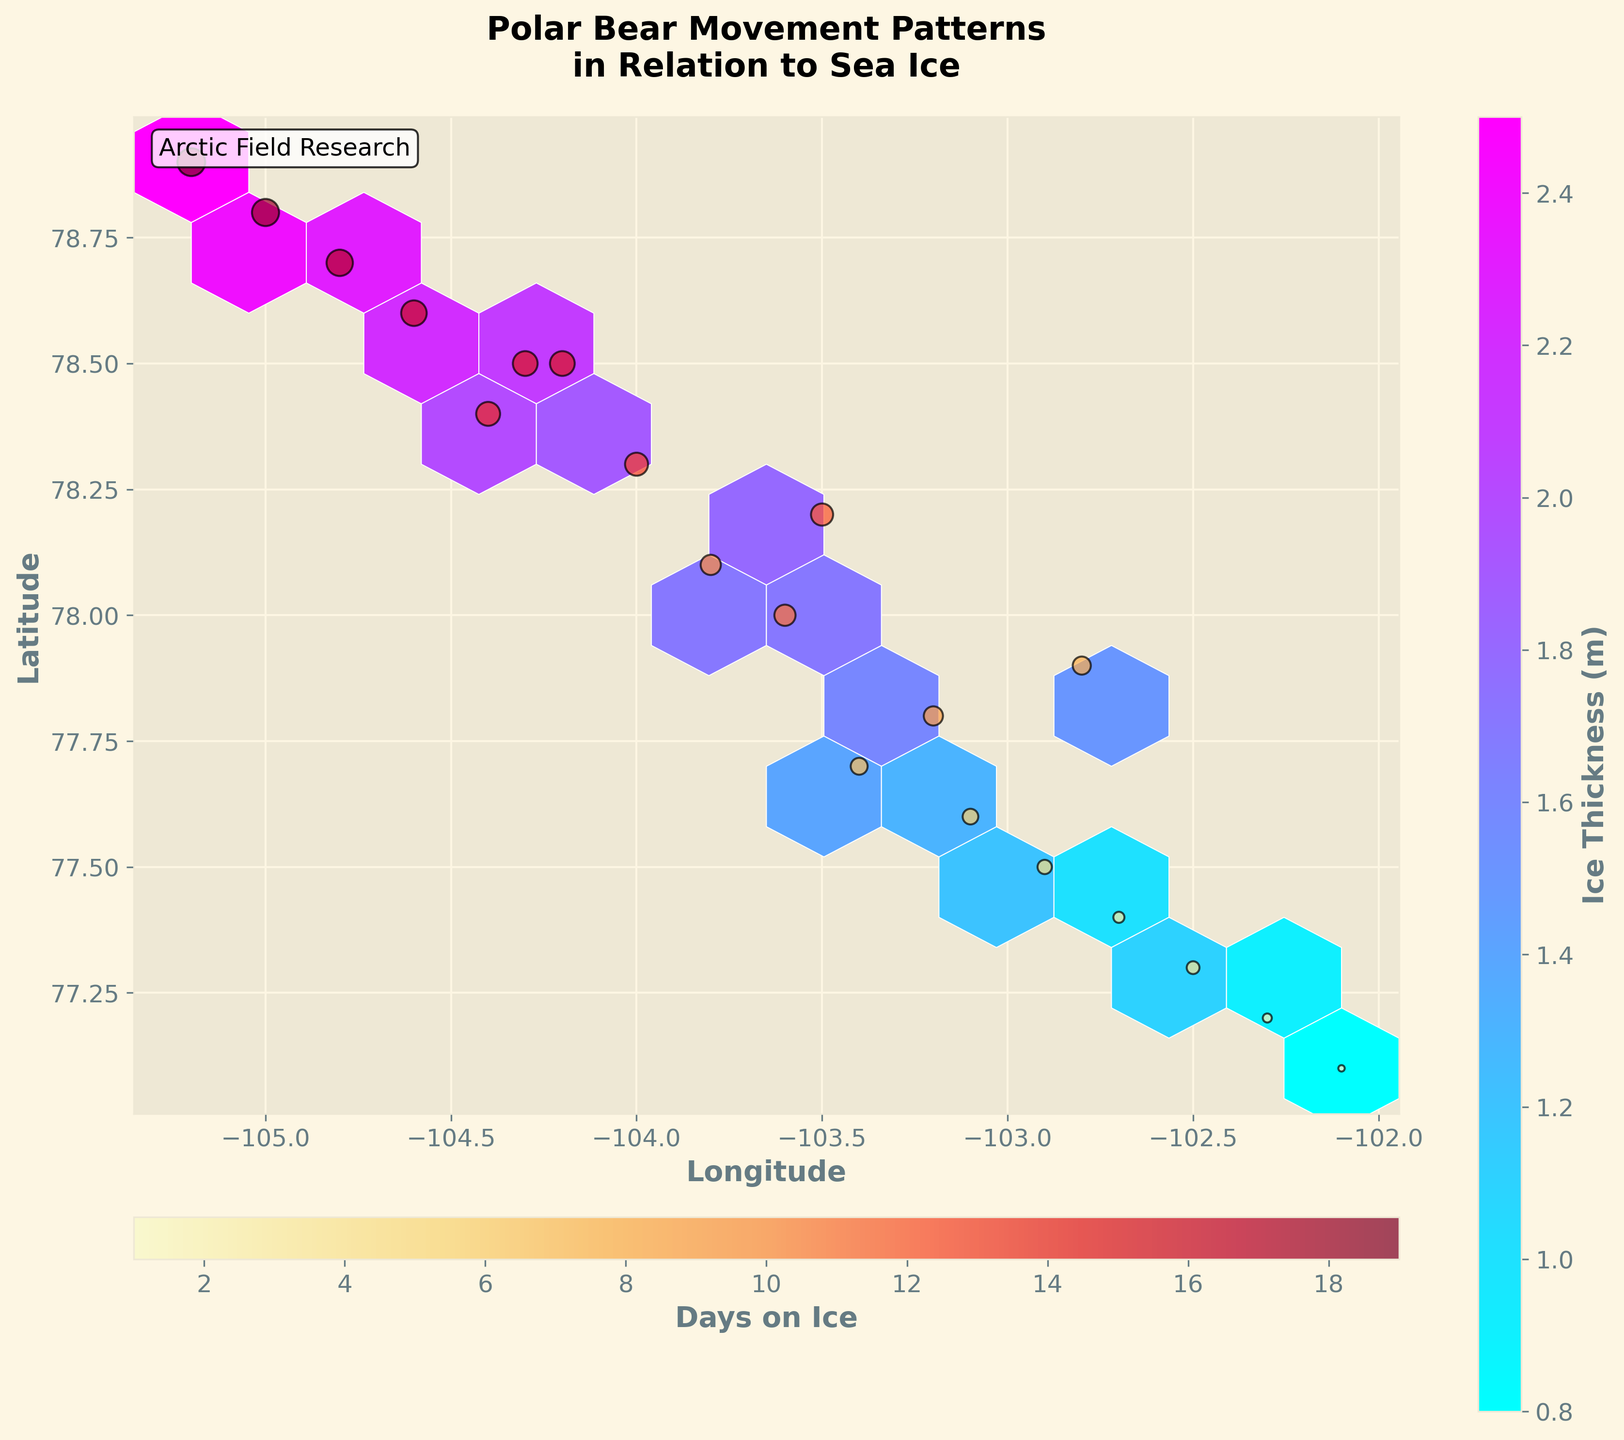What is the title of the hexbin plot? The title can be found at the top of the plot and is written in a bold, readable font.
Answer: Polar Bear Movement Patterns in Relation to Sea Ice What are the labels for the x-axis and y-axis on the plot? The x-axis and y-axis labels are located along the horizontal and vertical axes respectively, written in bold typeface for easy readability.
Answer: Longitude, Latitude Which color scale represents ice thickness? The color scale representing ice thickness is indicated by the color bar on the right side of the plot, which is labeled 'Ice Thickness (m)' and uses the 'cool' colormap.
Answer: cool What colormap is used for the 'Days on Ice' scatter plot? The colormap for the scatter plot 'Days on Ice' is shown near the second color bar at the bottom of the plot, labeled 'Days on Ice' and it uses the 'YlOrRd' colormap.
Answer: YlOrRd How many data points are represented in the scatter plot? Each data point in the scatter plot corresponds to a unique coordinate. By counting them or observing the number of points, we can identify there are 20 data points as provided in the data table.
Answer: 20 What is the scale of the bubble sizes in the scatter plot related to? The size of each bubble in the scatter plot is proportional to the number of days a polar bear spends on ice, which is visibly indicated by the size of each bubble differing accordingly.
Answer: Days on Ice What is the general relationship between latitude and ice thickness? Observing the hexbin plot, one can see a concentration of deeper colors (representing higher ice thickness) at higher latitudes, suggesting that as latitude increases, ice thickness tends to be higher.
Answer: Higher latitude, thicker ice Which region (Longitude and Latitude) shows the highest concentration of ice thickness? By looking at the hexbin plot and identifying the area with the densest and darkest hexagons, one can determine that the longitude around -105 and latitude around 78.8 shows the highest concentration of ice thickness.
Answer: Around -105 Longitude and 78.8 Latitude Are there more days spent on ice in thicker or thinner ice regions? Using the size and color of the bubbles in the scatter plot, which indicate 'Days on Ice', larger bubbles are noticeably in darker hexagons indicating thicker ice, suggesting more days are spent on thicker ice regions.
Answer: Thicker ice regions Is there a correlation between longitude and ice thickness? Observing the hexbin plot, darker hexagons representing thicker ice are generally found within a particular longitude range (around -105 to -104.2), suggesting that there is a correlation where certain longitudes have consistently thicker ice.
Answer: Yes, around -105 to -104.2 